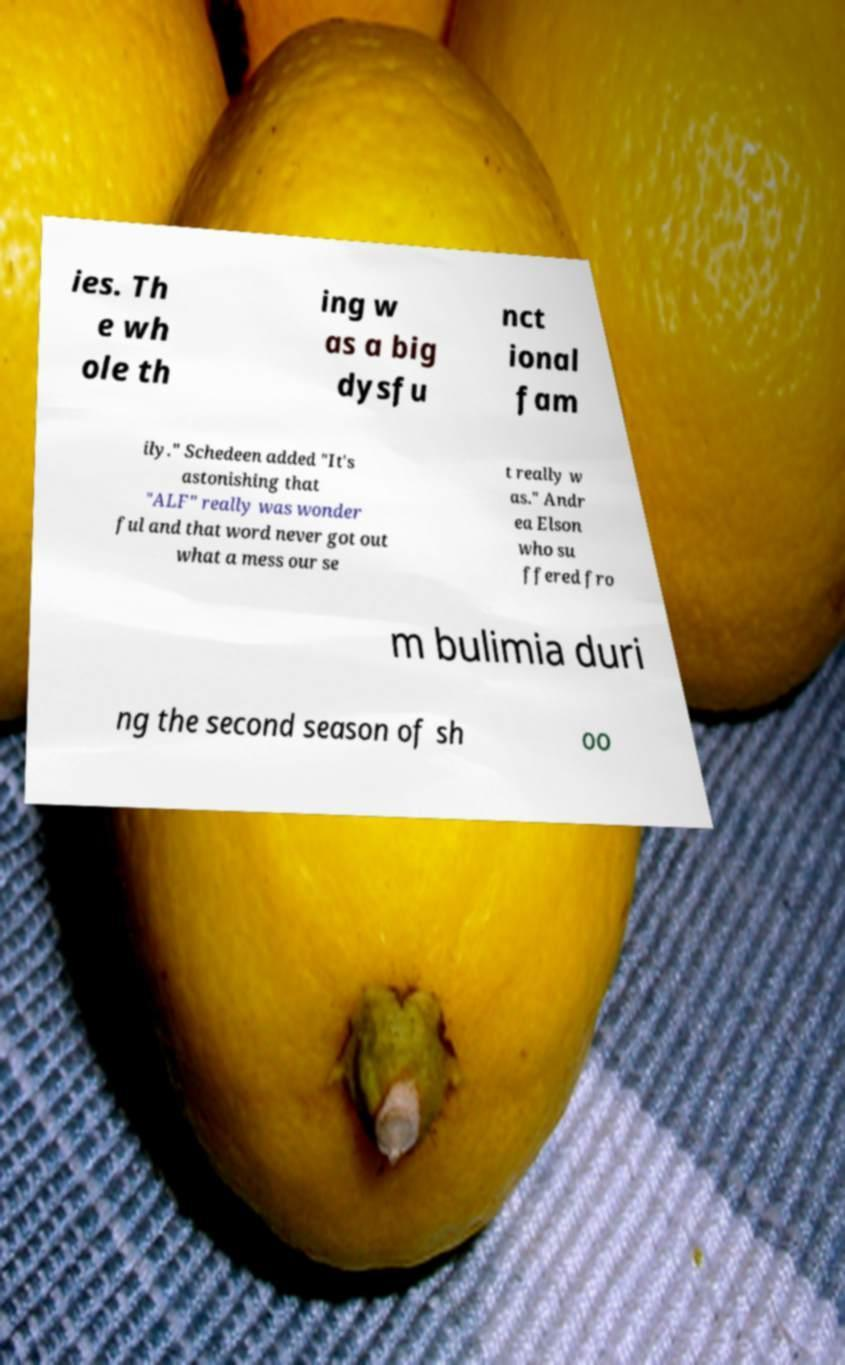Can you accurately transcribe the text from the provided image for me? ies. Th e wh ole th ing w as a big dysfu nct ional fam ily." Schedeen added "It's astonishing that "ALF" really was wonder ful and that word never got out what a mess our se t really w as." Andr ea Elson who su ffered fro m bulimia duri ng the second season of sh oo 